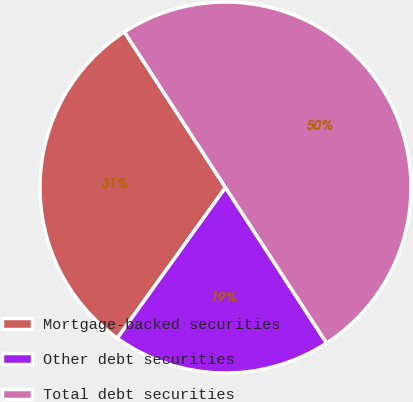Convert chart to OTSL. <chart><loc_0><loc_0><loc_500><loc_500><pie_chart><fcel>Mortgage-backed securities<fcel>Other debt securities<fcel>Total debt securities<nl><fcel>30.92%<fcel>19.08%<fcel>50.0%<nl></chart> 